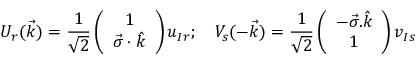<formula> <loc_0><loc_0><loc_500><loc_500>U _ { r } ( \vec { k } ) = \frac { 1 } { \sqrt { 2 } } \left ( \begin{array} { c } { 1 } \\ { { \vec { \sigma } \cdot \hat { k } } } \end{array} \right ) u _ { I r } ; \quad V _ { s } ( - \vec { k } ) = \frac { 1 } { \sqrt { 2 } } \left ( \begin{array} { c } { { - \vec { \sigma } . \hat { k } } } \\ { 1 } \end{array} \right ) v _ { I s }</formula> 